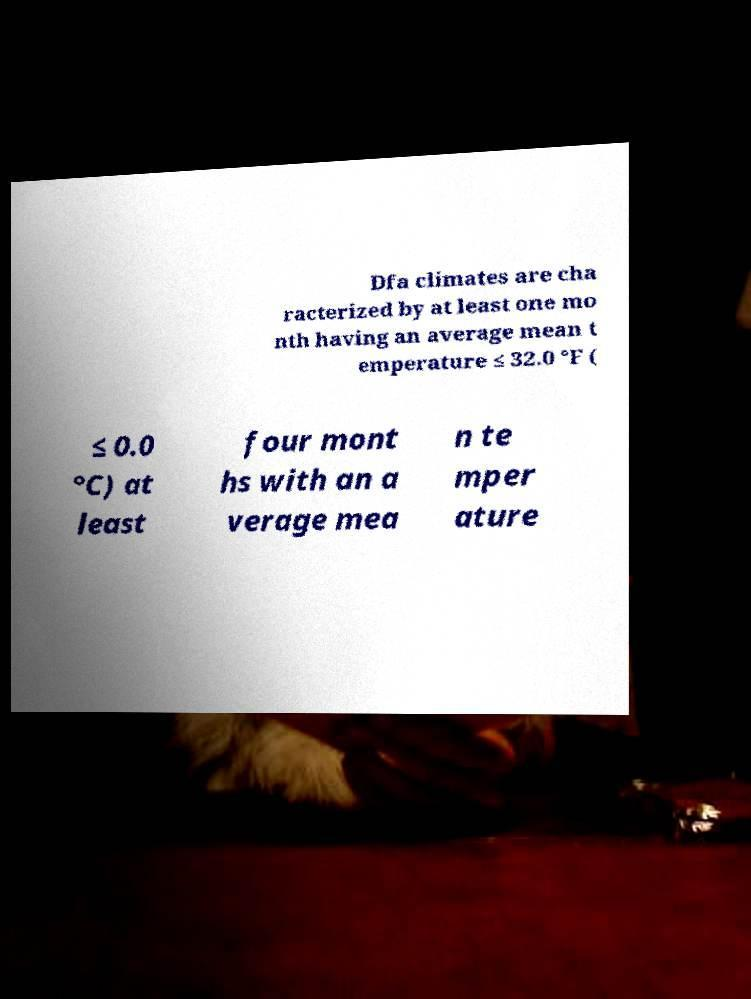Please identify and transcribe the text found in this image. Dfa climates are cha racterized by at least one mo nth having an average mean t emperature ≤ 32.0 °F ( ≤ 0.0 °C) at least four mont hs with an a verage mea n te mper ature 